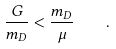<formula> <loc_0><loc_0><loc_500><loc_500>\frac { G } { m _ { D } } < \frac { m _ { D } } { \mu } \quad .</formula> 